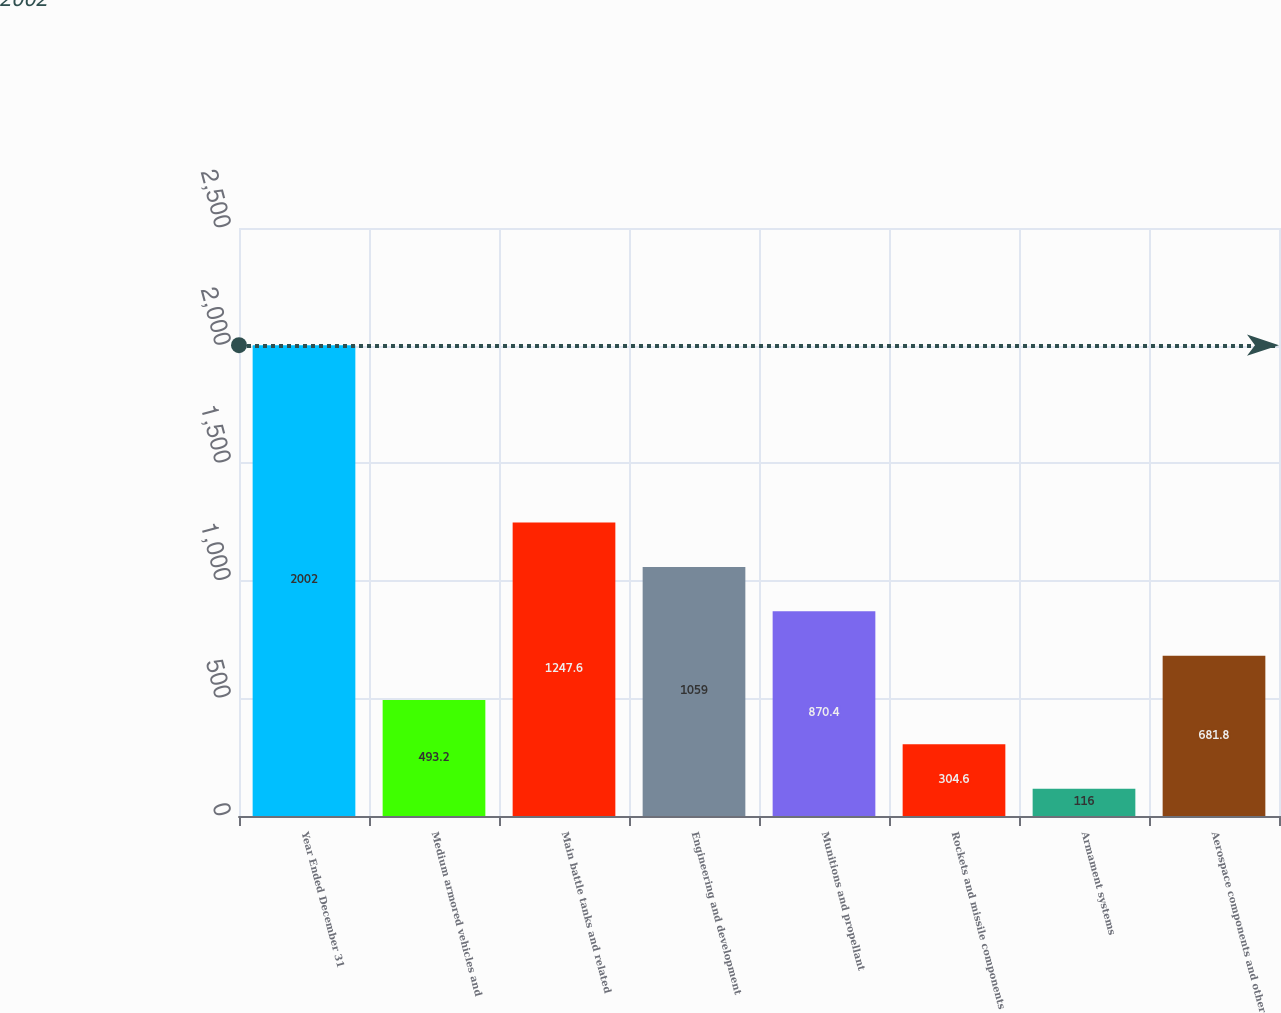Convert chart. <chart><loc_0><loc_0><loc_500><loc_500><bar_chart><fcel>Year Ended December 31<fcel>Medium armored vehicles and<fcel>Main battle tanks and related<fcel>Engineering and development<fcel>Munitions and propellant<fcel>Rockets and missile components<fcel>Armament systems<fcel>Aerospace components and other<nl><fcel>2002<fcel>493.2<fcel>1247.6<fcel>1059<fcel>870.4<fcel>304.6<fcel>116<fcel>681.8<nl></chart> 